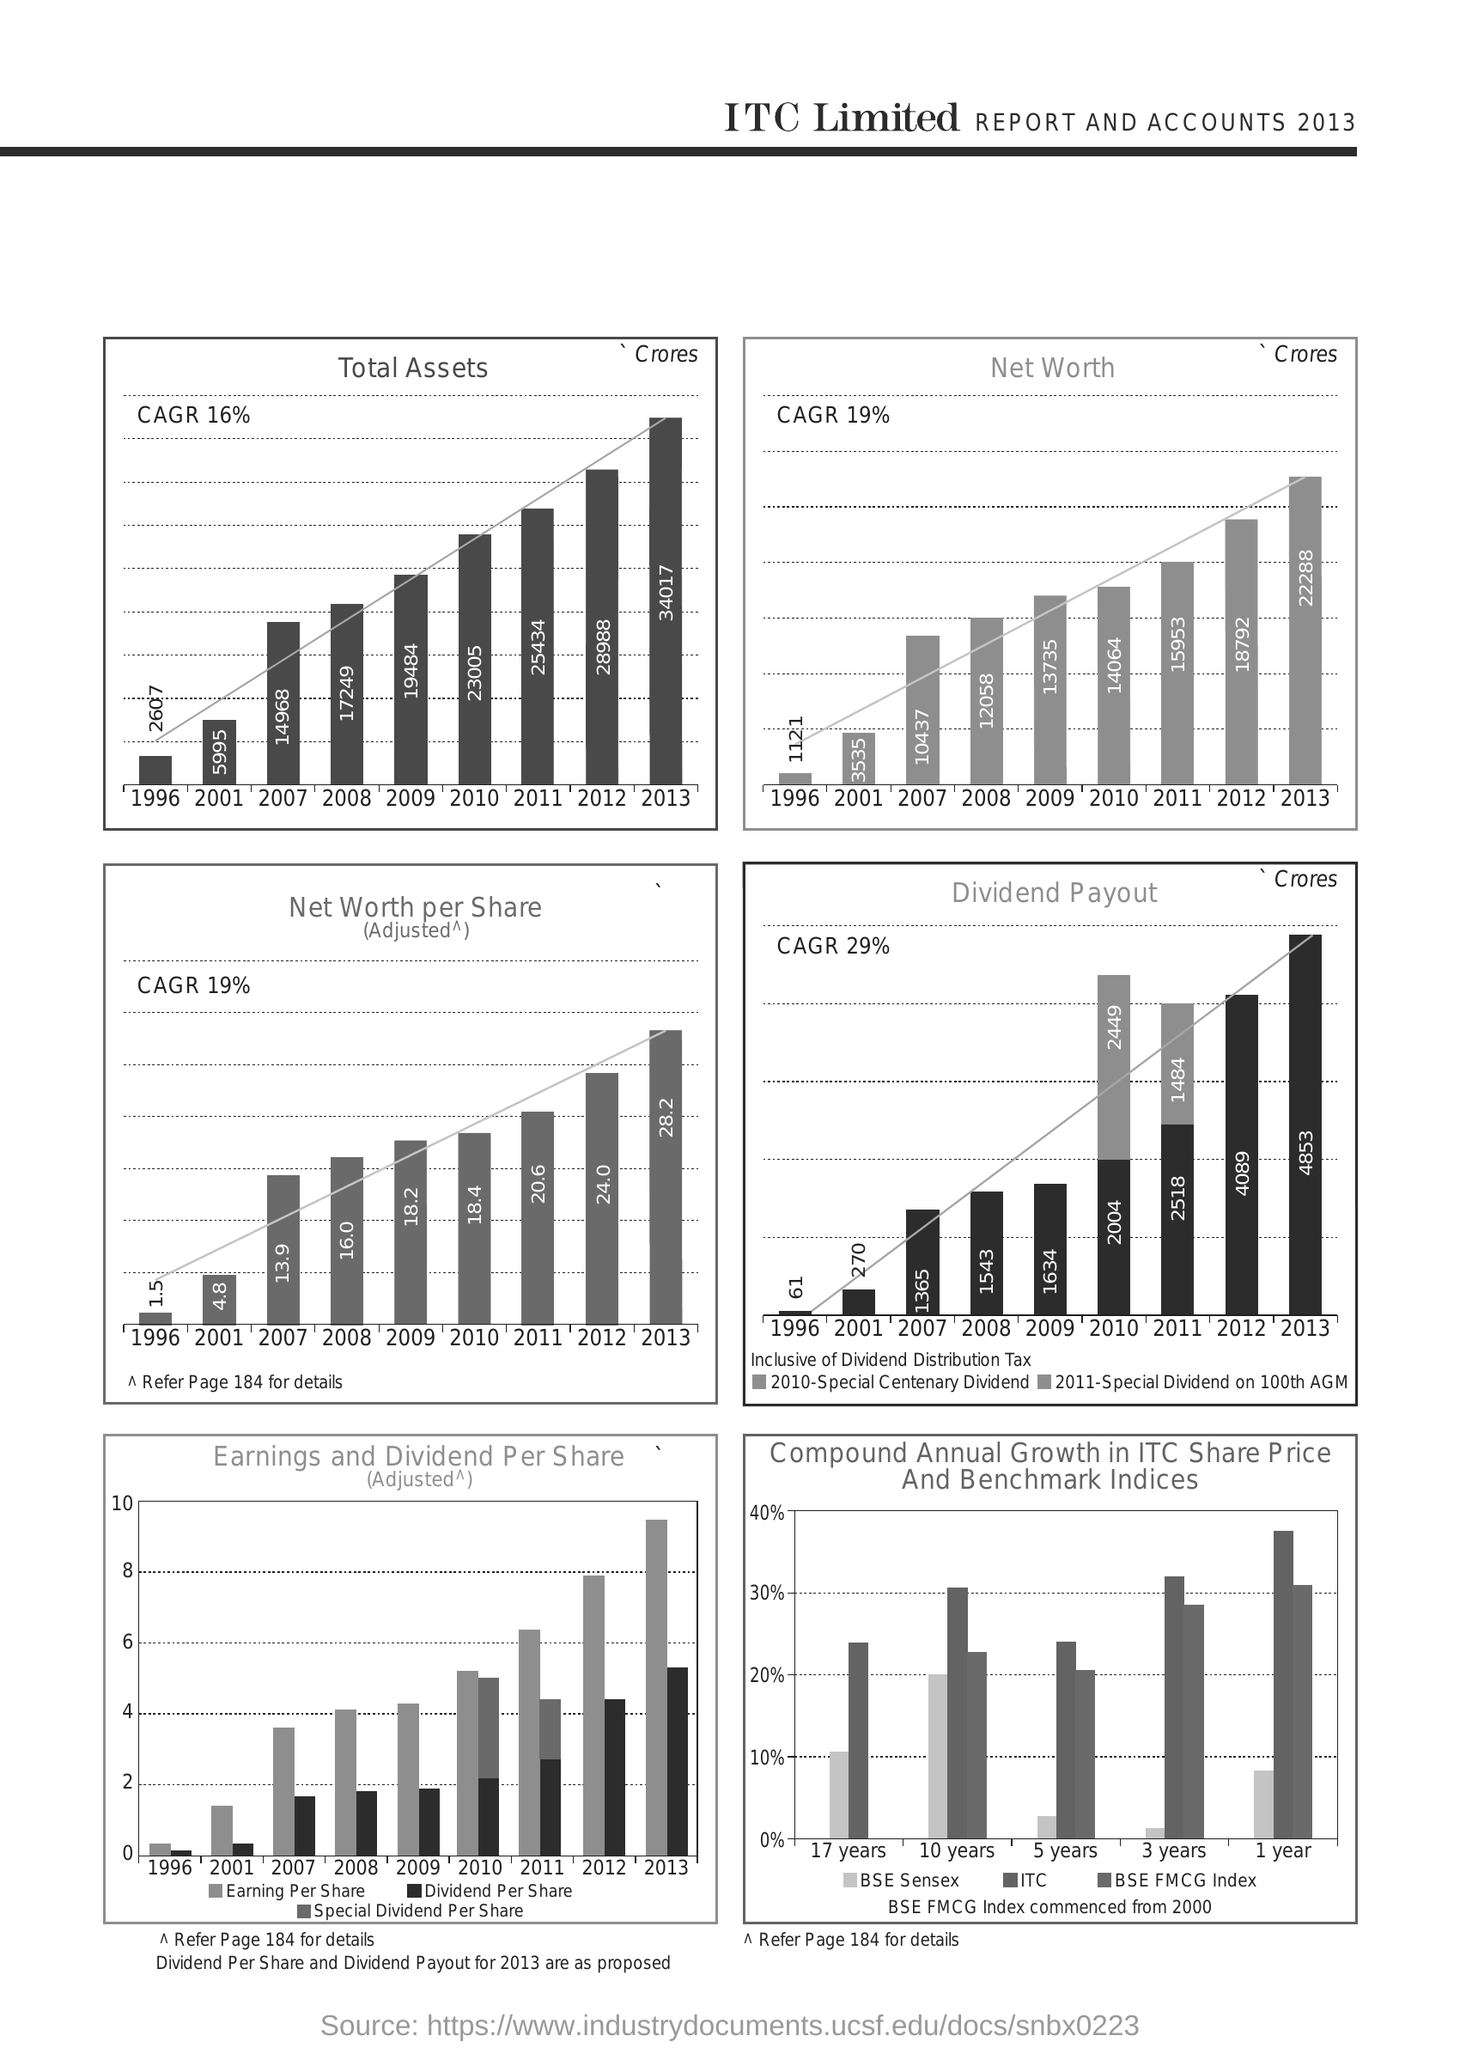"REPORT AND ACCOUNTS" of which year is given?
Your answer should be very brief. 2013. Which year has "Total Assets" of 34017 Crores?
Ensure brevity in your answer.  2013. What percentage of CAGR is shown in "Total Assets" graph?
Your answer should be compact. 16. What percentage of CAGR is shown in "Net Worth" graph?
Provide a short and direct response. 19. Which year has "Net Worth" of 22288 Crores?
Provide a short and direct response. 2013. Which year has "Net Worth per share" of 24.0?
Your response must be concise. 2012. Which year has "Dividend Payout" of 1543 Crores?
Give a very brief answer. 2008. What percentage of CAGR is shown in "Dividend Payout" graph?
Your answer should be very brief. 29%. Which year has minimum "Dividend Payout"?
Provide a short and direct response. 1996. Which year has "Net Worth" of 10437 Crores?
Your answer should be very brief. 2007. 